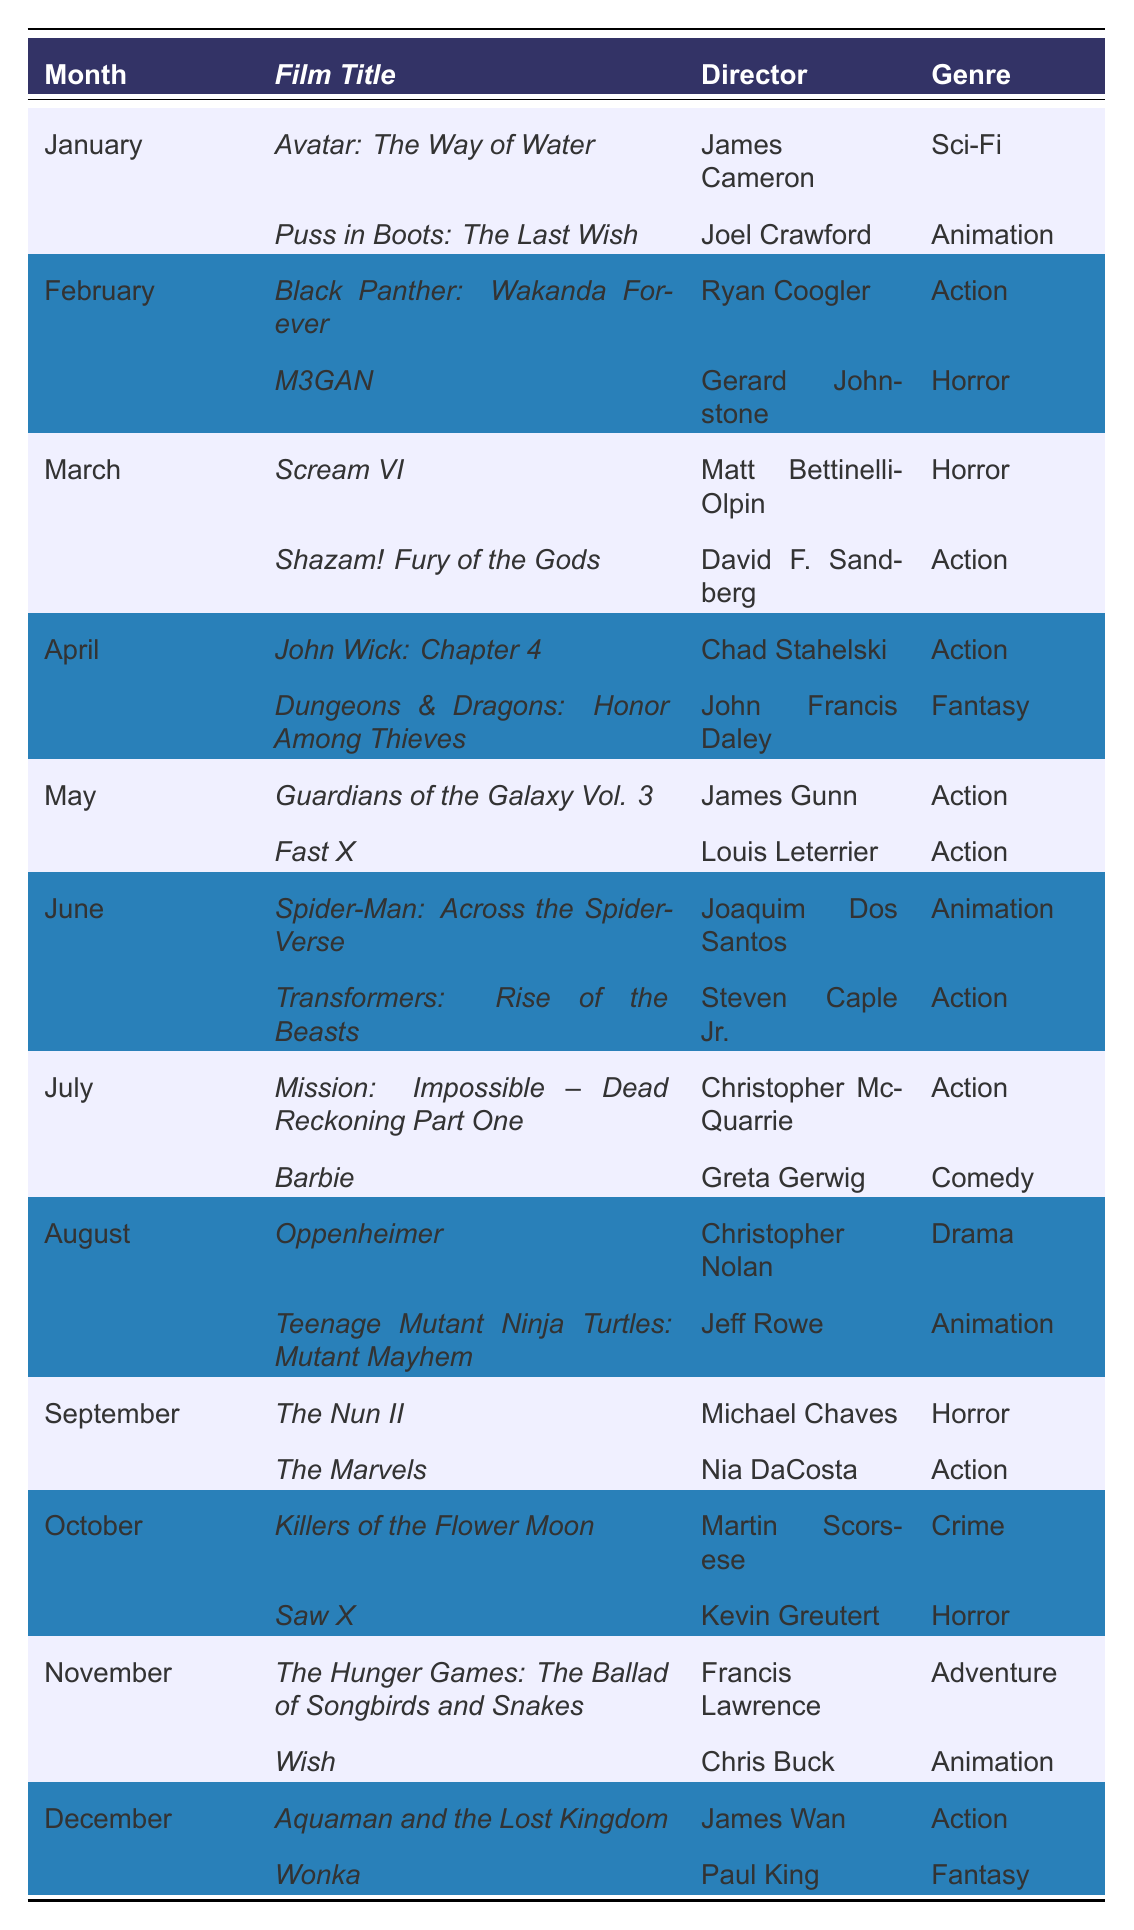What films were released in January? According to the table, the films released in January are "Avatar: The Way of Water" and "Puss in Boots: The Last Wish."
Answer: Avatar: The Way of Water, Puss in Boots: The Last Wish Who directed "The Nun II"? The table shows that "The Nun II" was directed by Michael Chaves.
Answer: Michael Chaves How many films were released in March? The table indicates that two films were released in March: "Scream VI" and "Shazam! Fury of the Gods."
Answer: 2 Which film is categorized as a Drama and when was it released? The table lists "Oppenheimer" as a Drama, released on August 4, 2023.
Answer: Oppenheimer, August 4, 2023 In which month was "Guardians of the Galaxy Vol. 3" released? The table states that "Guardians of the Galaxy Vol. 3" was released in May.
Answer: May Which director has the most films released in a single month? By reviewing the table, James Gunn, with "Guardians of the Galaxy Vol. 3" and another film released in May, has multiple films in May, but within available data, it appears that no one has more than one film in a given month.
Answer: No director has multiple films in a month How many horror films were released in total throughout the year? The table indicates three horror films: "M3GAN," "Scream VI," "The Nun II," and one more "Saw X," totaling four horror films released in 2023.
Answer: 4 What genre was the film "Transformers: Rise of the Beasts"? The table mentions that "Transformers: Rise of the Beasts" belongs to the Action genre.
Answer: Action Which month had the highest number of action films? By examining the table, we find that May saw three films categorized as Action: "Guardians of the Galaxy Vol. 3," "Fast X," and "Transformers: Rise of the Beasts."
Answer: May Is there a film directed by Christopher Nolan in the table? The table confirms that "Oppenheimer," directed by Christopher Nolan, is present in the film releases.
Answer: Yes What is the average genre count per month from the table? There are 24 films across 12 months; dividing gives 2 films per month on average, resulting in each month featuring about 2 genres.
Answer: 2 